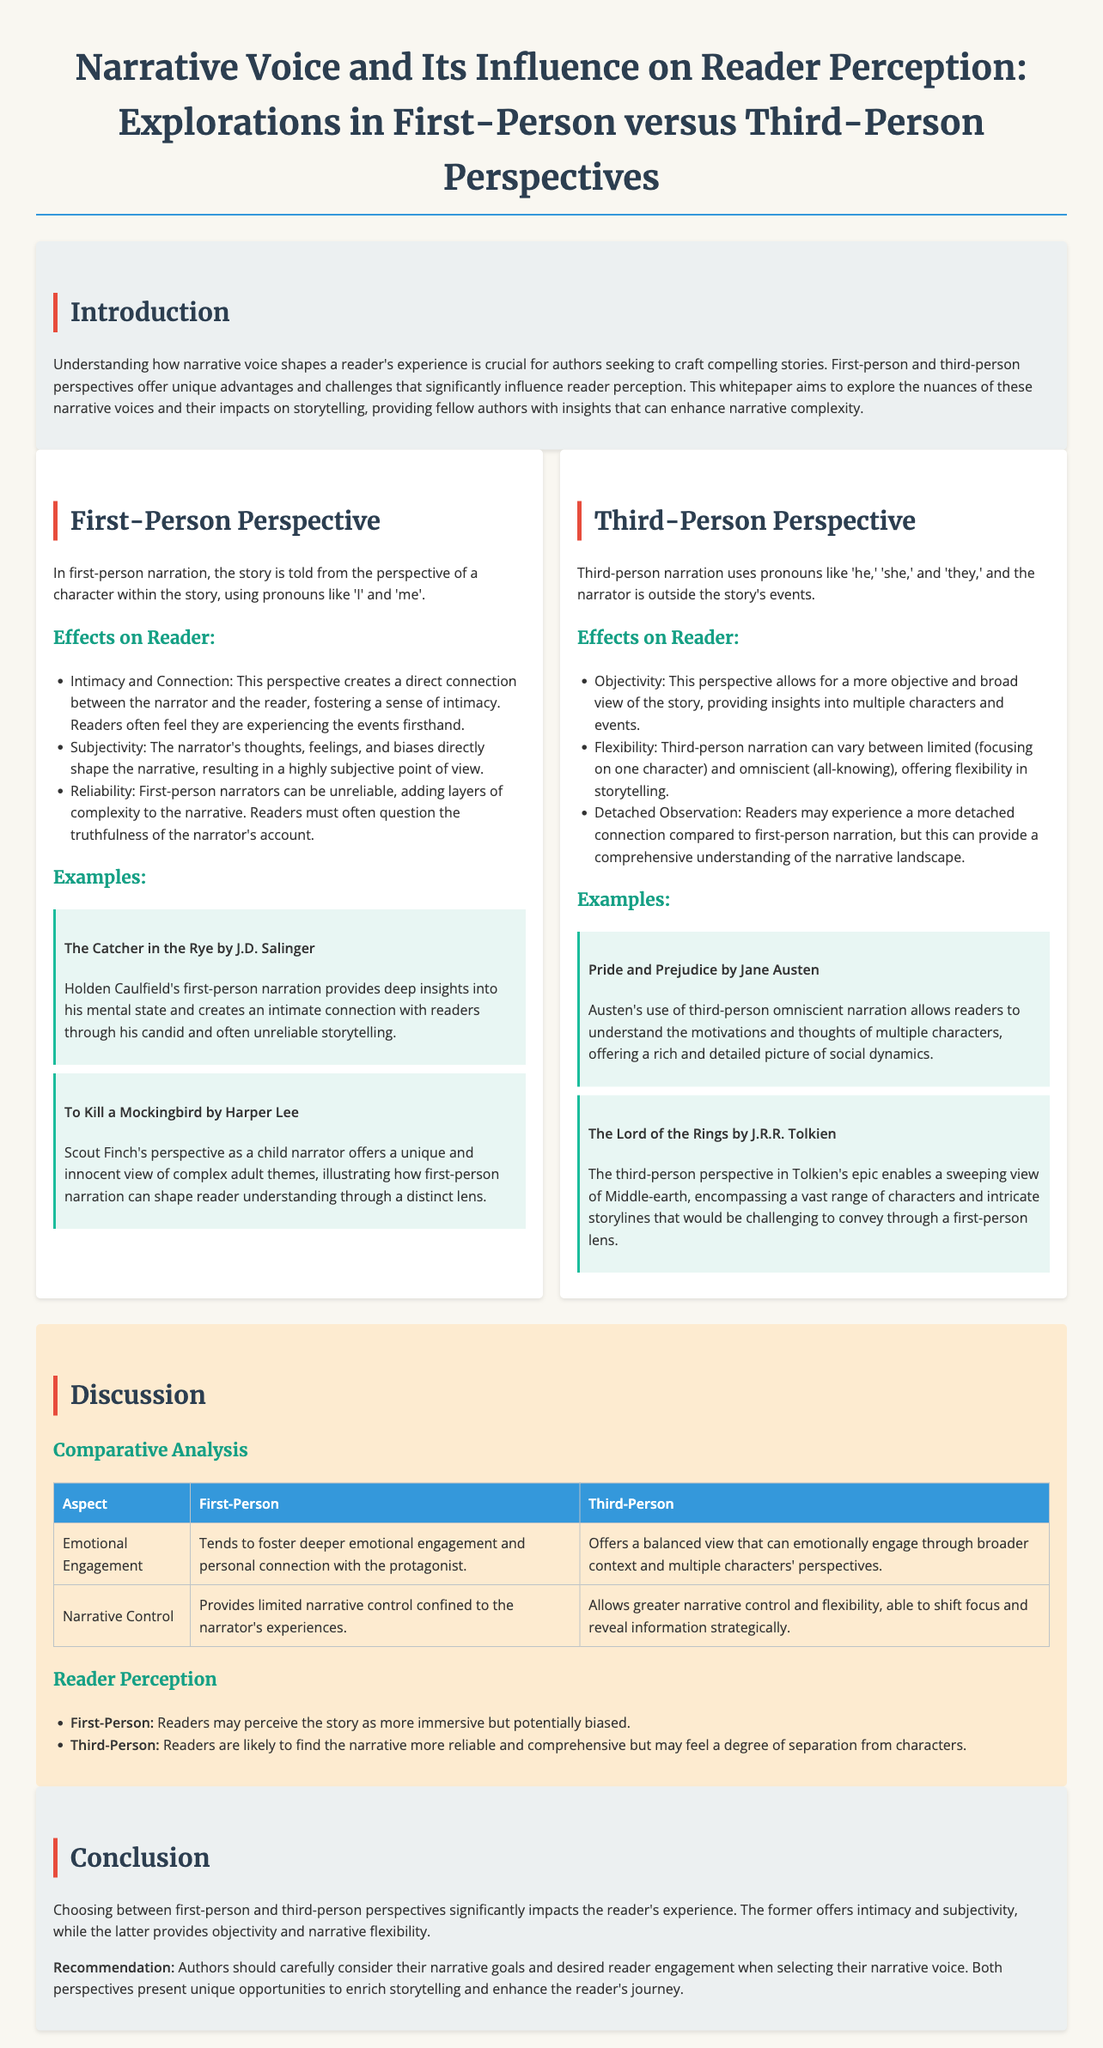what is the main focus of the whitepaper? The main focus of the whitepaper is to explore the nuances of narrative voices and their impacts on storytelling, particularly comparing first-person and third-person perspectives.
Answer: narrative voices and their impacts on storytelling who is the author of "The Catcher in the Rye"? "The Catcher in the Rye" is authored by J.D. Salinger, as stated in the example section related to first-person perspective.
Answer: J.D. Salinger how does first-person narration impact reader perception? The document outlines that first-person narration impacts reader perception by fostering intimacy and offering a subjective viewpoint.
Answer: intimacy and subjective viewpoint what perspective allows for a broader view of the story? The document states that third-person narration allows for a more objective and broad view of the story.
Answer: third-person narration which chapter discusses comparative analysis between first-person and third-person perspectives? The section titled "Comparative Analysis" is dedicated to discussing the differences between first-person and third-person perspectives.
Answer: Comparative Analysis what is a potential downside of first-person narrators mentioned in the document? The document mentions that first-person narrators can be unreliable, which adds complexity to the narrative.
Answer: unreliable how does Pride and Prejudice utilize narrative perspective? Pride and Prejudice uses third-person omniscient narration, providing insights into multiple characters' thoughts and motivations.
Answer: third-person omniscient narration what is the recommendation for authors regarding narrative voice? The recommendation is for authors to carefully consider their narrative goals and desired reader engagement when selecting their narrative voice.
Answer: consider narrative goals and reader engagement 